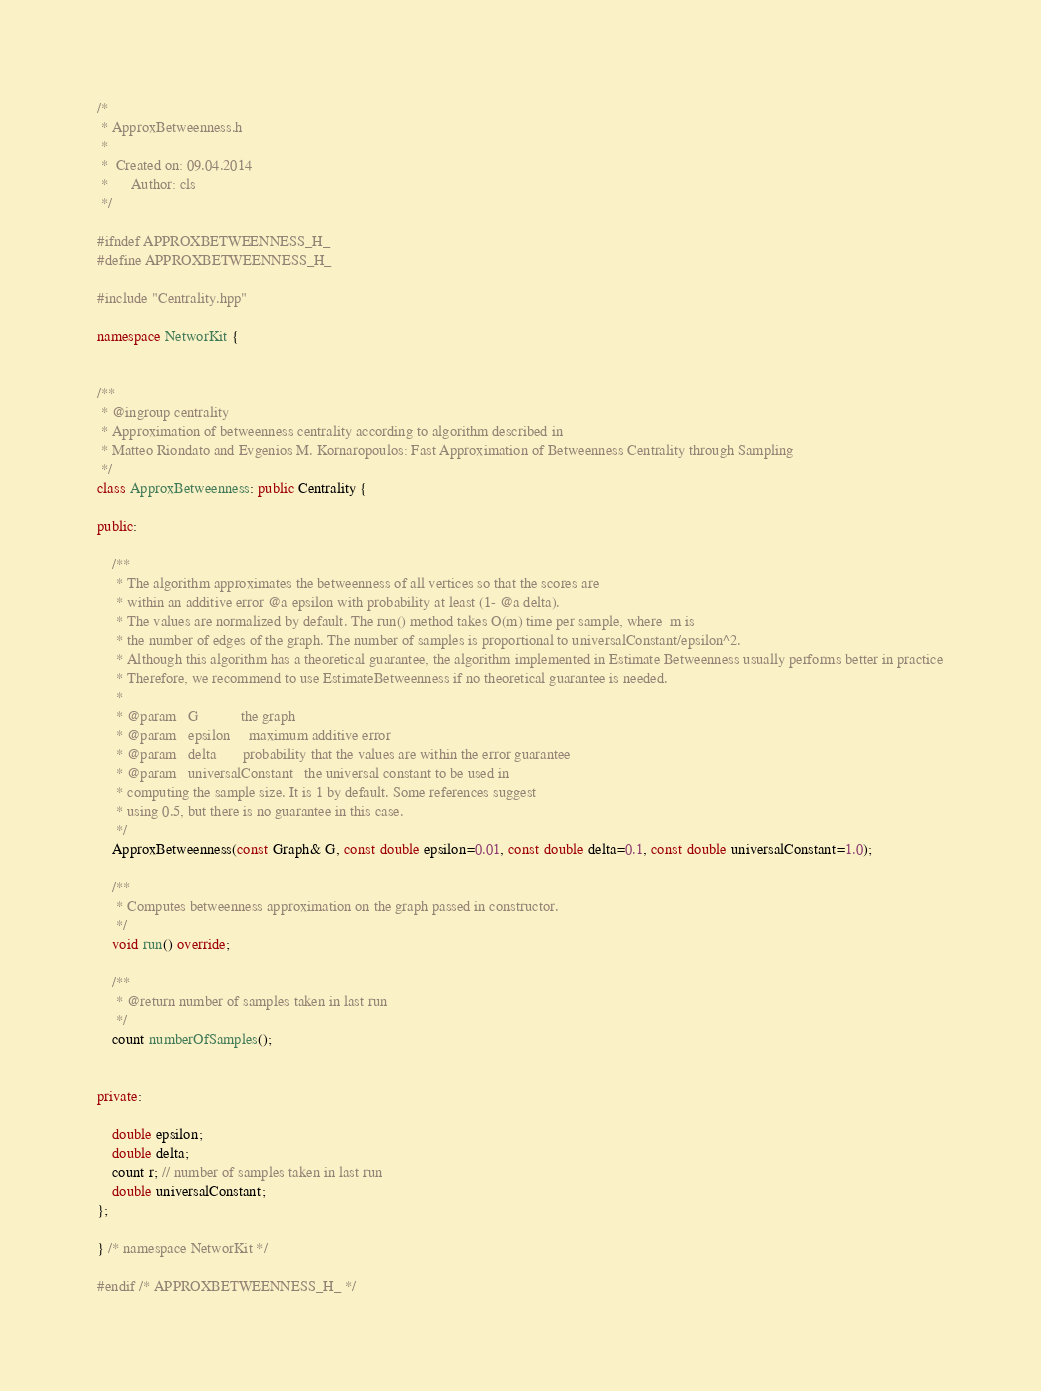Convert code to text. <code><loc_0><loc_0><loc_500><loc_500><_C++_>/*
 * ApproxBetweenness.h
 *
 *  Created on: 09.04.2014
 *      Author: cls
 */

#ifndef APPROXBETWEENNESS_H_
#define APPROXBETWEENNESS_H_

#include "Centrality.hpp"

namespace NetworKit {


/**
 * @ingroup centrality
 * Approximation of betweenness centrality according to algorithm described in
 * Matteo Riondato and Evgenios M. Kornaropoulos: Fast Approximation of Betweenness Centrality through Sampling
 */
class ApproxBetweenness: public Centrality {

public:

	/**
	 * The algorithm approximates the betweenness of all vertices so that the scores are
	 * within an additive error @a epsilon with probability at least (1- @a delta).
	 * The values are normalized by default. The run() method takes O(m) time per sample, where  m is
	 * the number of edges of the graph. The number of samples is proportional to universalConstant/epsilon^2.
	 * Although this algorithm has a theoretical guarantee, the algorithm implemented in Estimate Betweenness usually performs better in practice
	 * Therefore, we recommend to use EstimateBetweenness if no theoretical guarantee is needed.
	 *
	 * @param	G			the graph
	 * @param	epsilon		maximum additive error
	 * @param	delta		probability that the values are within the error guarantee
	 * @param   universalConstant   the universal constant to be used in
	 * computing the sample size. It is 1 by default. Some references suggest
	 * using 0.5, but there is no guarantee in this case.
	 */
	ApproxBetweenness(const Graph& G, const double epsilon=0.01, const double delta=0.1, const double universalConstant=1.0);

	/**
	 * Computes betweenness approximation on the graph passed in constructor.
	 */
	void run() override;

	/**
	 * @return number of samples taken in last run
	 */
	count numberOfSamples();


private:

	double epsilon;
	double delta;
	count r; // number of samples taken in last run
	double universalConstant;
};

} /* namespace NetworKit */

#endif /* APPROXBETWEENNESS_H_ */
</code> 